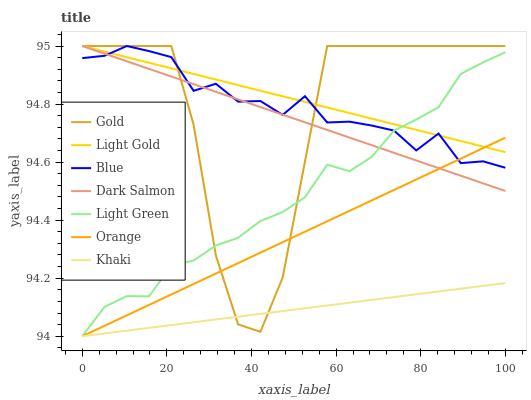Does Gold have the minimum area under the curve?
Answer yes or no. No. Does Gold have the maximum area under the curve?
Answer yes or no. No. Is Khaki the smoothest?
Answer yes or no. No. Is Khaki the roughest?
Answer yes or no. No. Does Gold have the lowest value?
Answer yes or no. No. Does Khaki have the highest value?
Answer yes or no. No. Is Khaki less than Blue?
Answer yes or no. Yes. Is Light Gold greater than Khaki?
Answer yes or no. Yes. Does Khaki intersect Blue?
Answer yes or no. No. 